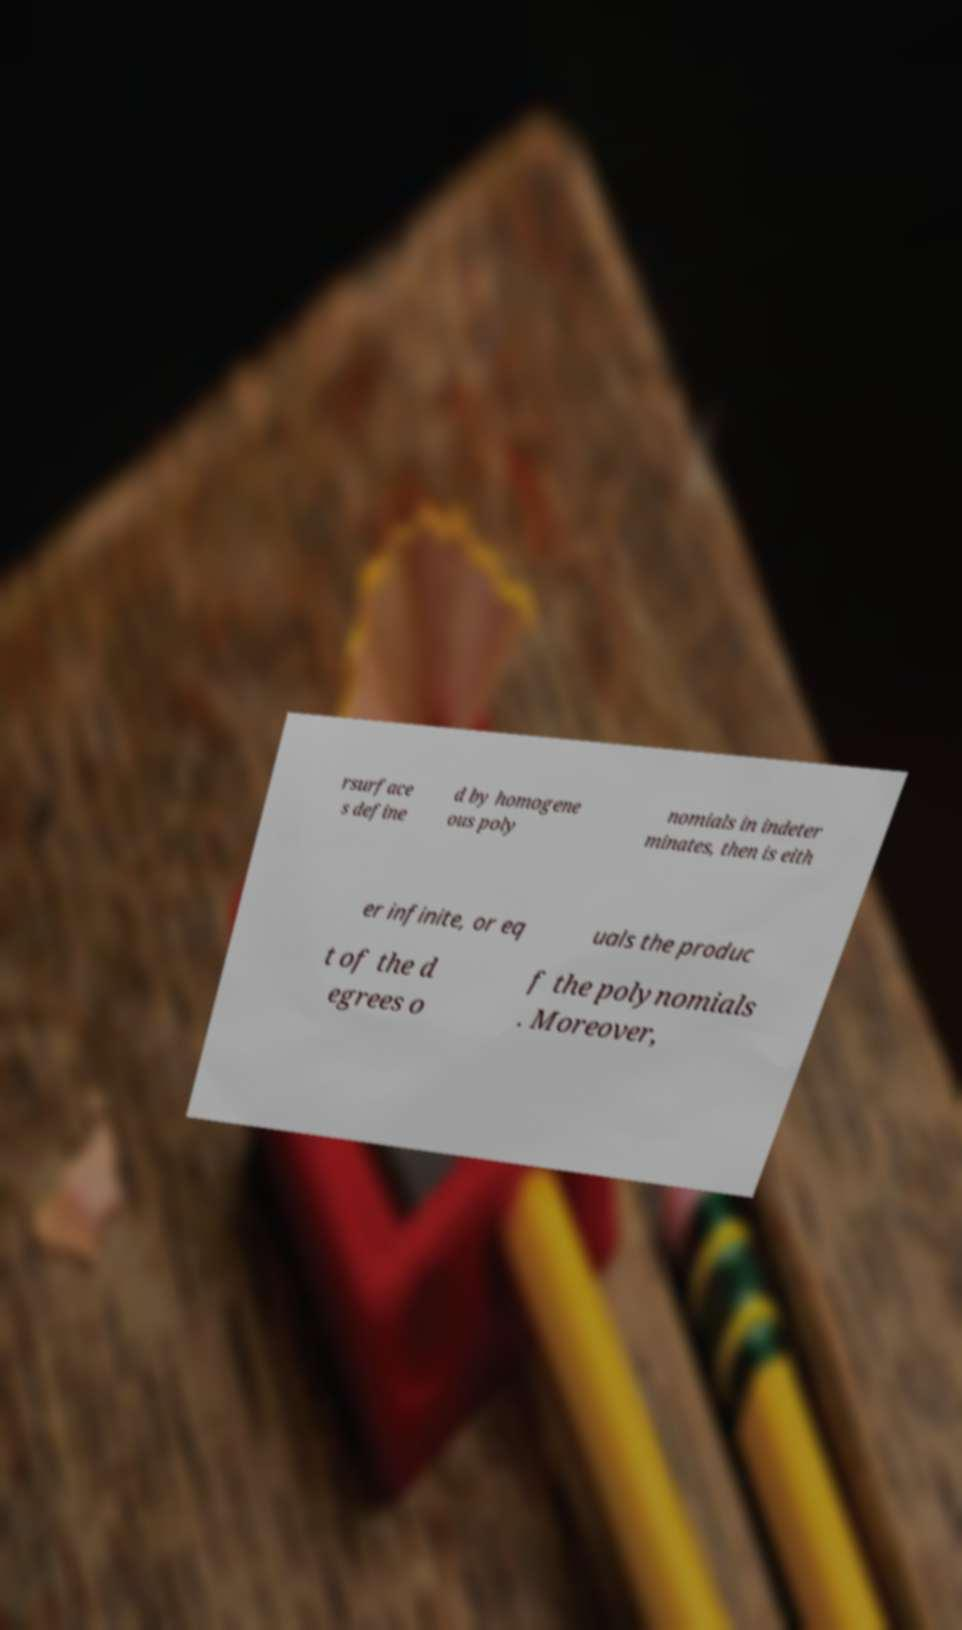For documentation purposes, I need the text within this image transcribed. Could you provide that? rsurface s define d by homogene ous poly nomials in indeter minates, then is eith er infinite, or eq uals the produc t of the d egrees o f the polynomials . Moreover, 